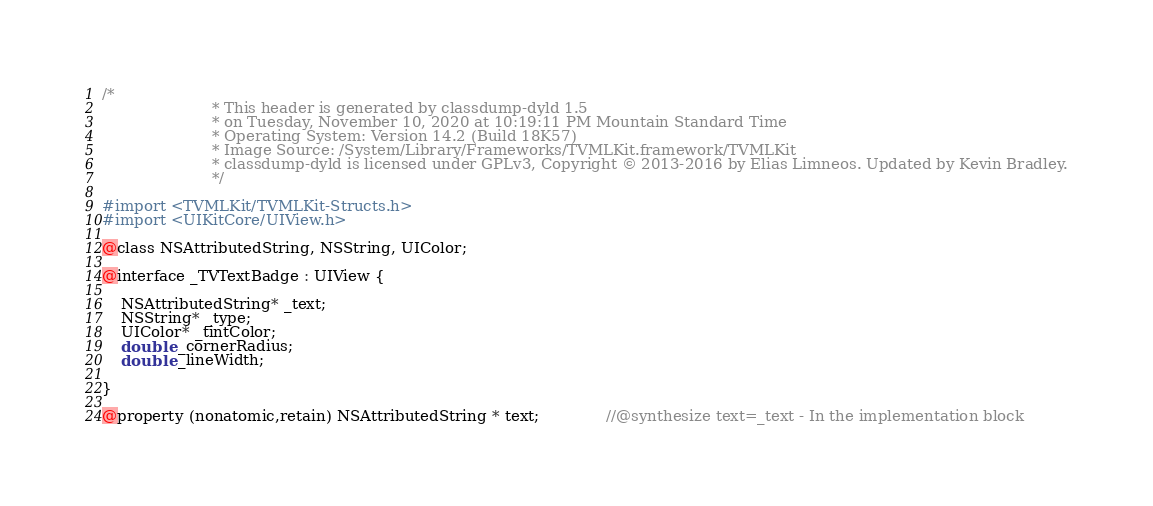<code> <loc_0><loc_0><loc_500><loc_500><_C_>/*
                       * This header is generated by classdump-dyld 1.5
                       * on Tuesday, November 10, 2020 at 10:19:11 PM Mountain Standard Time
                       * Operating System: Version 14.2 (Build 18K57)
                       * Image Source: /System/Library/Frameworks/TVMLKit.framework/TVMLKit
                       * classdump-dyld is licensed under GPLv3, Copyright © 2013-2016 by Elias Limneos. Updated by Kevin Bradley.
                       */

#import <TVMLKit/TVMLKit-Structs.h>
#import <UIKitCore/UIView.h>

@class NSAttributedString, NSString, UIColor;

@interface _TVTextBadge : UIView {

	NSAttributedString* _text;
	NSString* _type;
	UIColor* _tintColor;
	double _cornerRadius;
	double _lineWidth;

}

@property (nonatomic,retain) NSAttributedString * text;              //@synthesize text=_text - In the implementation block</code> 